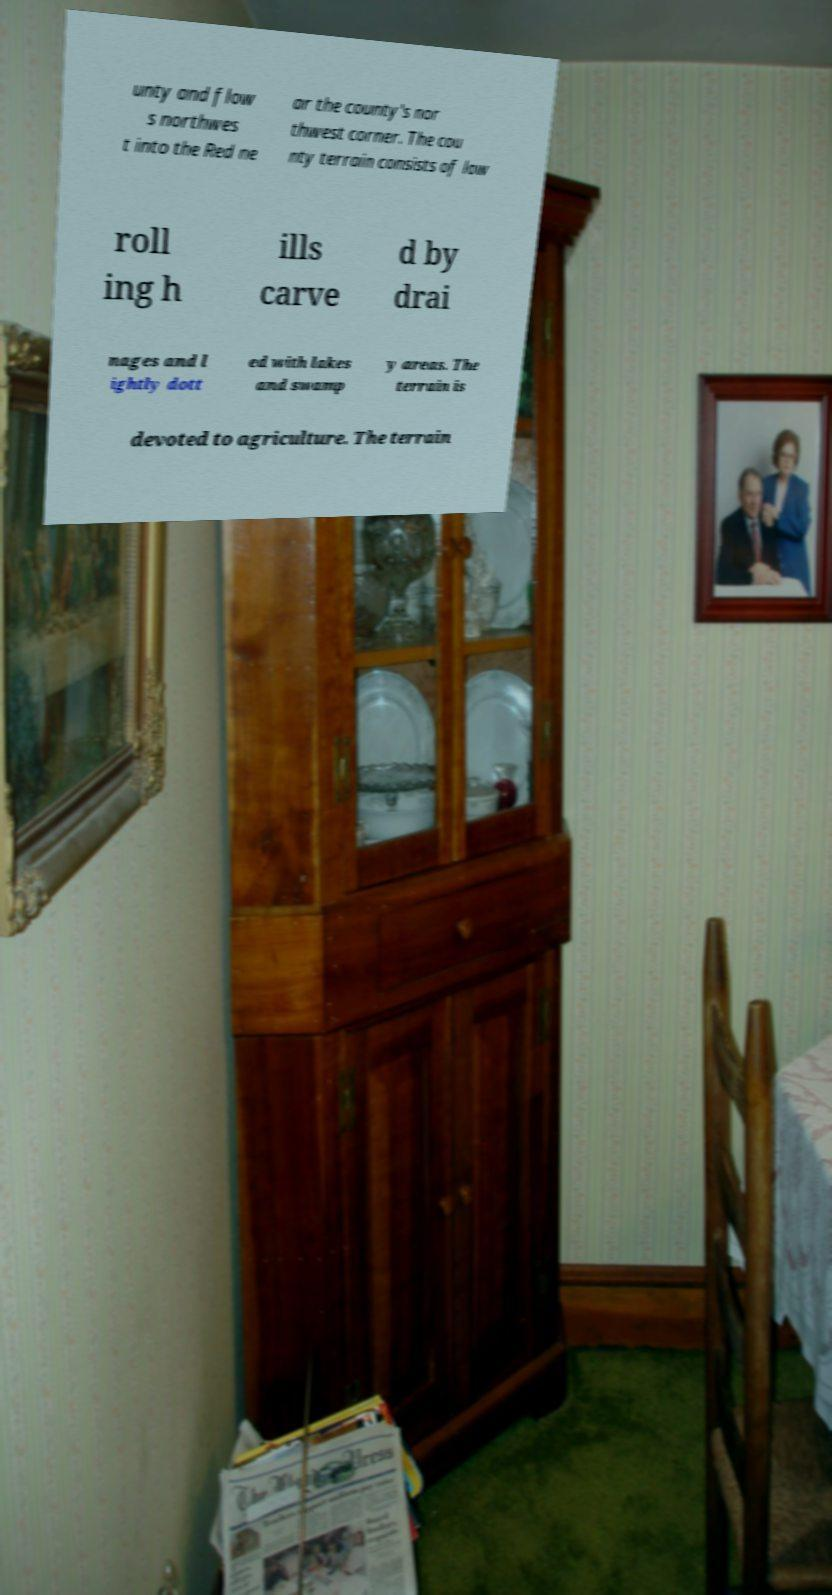Please identify and transcribe the text found in this image. unty and flow s northwes t into the Red ne ar the county's nor thwest corner. The cou nty terrain consists of low roll ing h ills carve d by drai nages and l ightly dott ed with lakes and swamp y areas. The terrain is devoted to agriculture. The terrain 